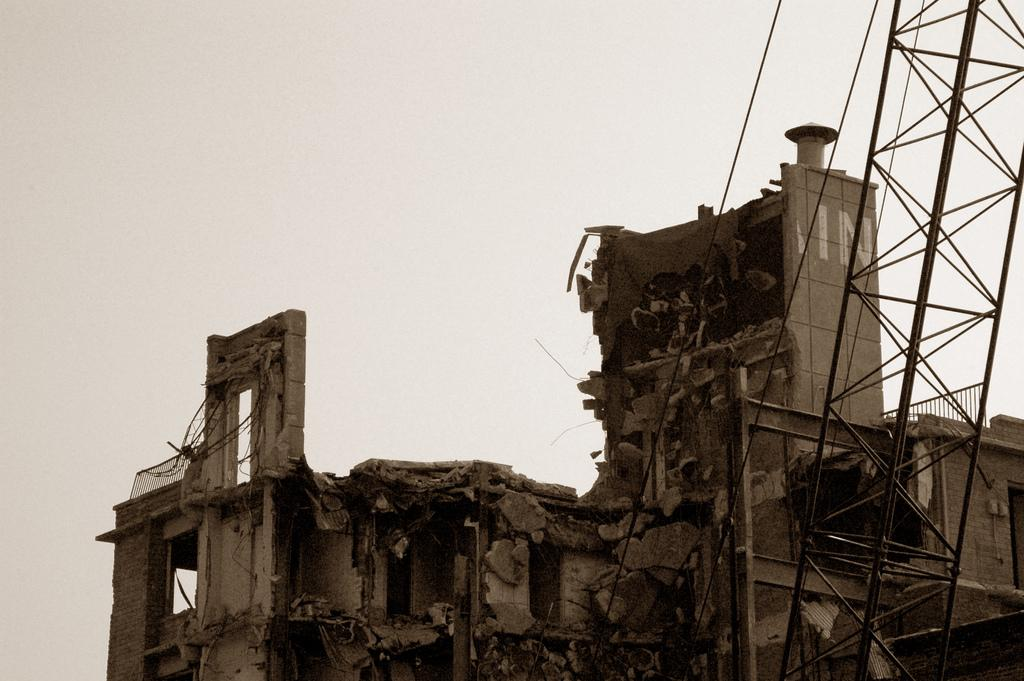What type of structure is present in the image? There is a building in the image. What is the condition of the building? The building appears to be collapsed. What can be seen on the right side of the image? There is a metal stand on the right side of the image. What is visible at the top of the image? The sky is visible at the top of the image. What type of seed can be seen sprouting from the collapsed building in the image? There is no seed present in the image, and the building appears to be collapsed, not sprouting any seeds. 